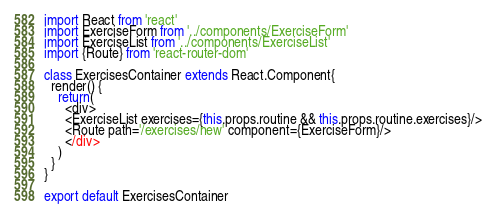<code> <loc_0><loc_0><loc_500><loc_500><_JavaScript_>import React from 'react'
import ExerciseForm from '../components/ExerciseForm'
import ExerciseList from '../components/ExerciseList'
import {Route} from 'react-router-dom'

class ExercisesContainer extends React.Component{
  render() {
    return(
      <div>
      <ExerciseList exercises={this.props.routine && this.props.routine.exercises}/>
      <Route path='/exercises/new' component={ExerciseForm}/>
      </div>
    )
  }
}

export default ExercisesContainer
</code> 